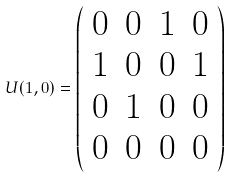Convert formula to latex. <formula><loc_0><loc_0><loc_500><loc_500>U ( 1 , 0 ) = \left ( \begin{array} { c c c c } { 0 } & { 0 } & { 1 } & { 0 } \\ { 1 } & { 0 } & { 0 } & { 1 } \\ { 0 } & { 1 } & { 0 } & { 0 } \\ { 0 } & { 0 } & { 0 } & { 0 } \end{array} \right )</formula> 